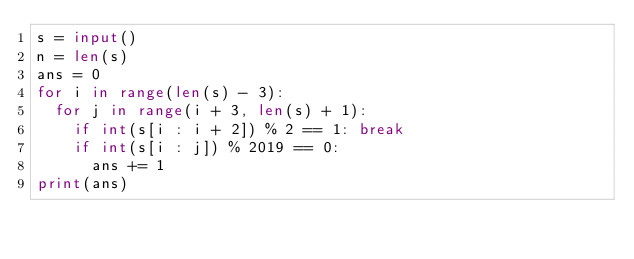<code> <loc_0><loc_0><loc_500><loc_500><_Python_>s = input()
n = len(s)
ans = 0
for i in range(len(s) - 3):
  for j in range(i + 3, len(s) + 1):
    if int(s[i : i + 2]) % 2 == 1: break
    if int(s[i : j]) % 2019 == 0:
      ans += 1
print(ans)</code> 